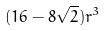<formula> <loc_0><loc_0><loc_500><loc_500>( 1 6 - 8 \sqrt { 2 } ) r ^ { 3 }</formula> 